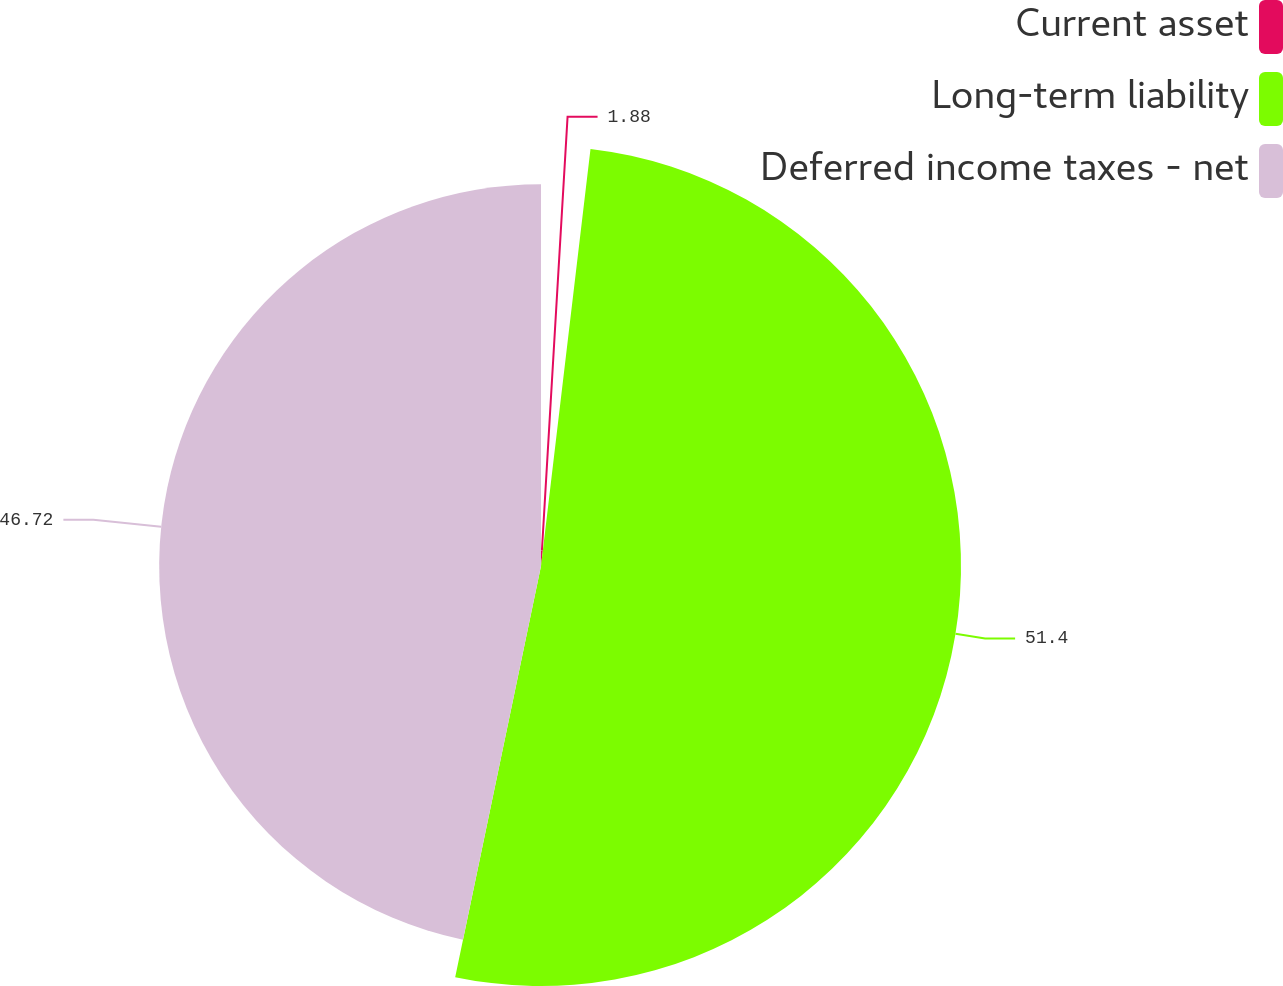Convert chart. <chart><loc_0><loc_0><loc_500><loc_500><pie_chart><fcel>Current asset<fcel>Long-term liability<fcel>Deferred income taxes - net<nl><fcel>1.88%<fcel>51.39%<fcel>46.72%<nl></chart> 